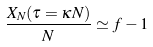<formula> <loc_0><loc_0><loc_500><loc_500>\frac { X _ { N } ( \tau = \kappa N ) } { N } \simeq f - 1</formula> 